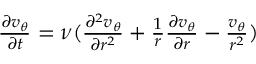Convert formula to latex. <formula><loc_0><loc_0><loc_500><loc_500>\begin{array} { r } { \frac { \partial v _ { \theta } } { \partial t } = \nu ( \frac { \partial ^ { 2 } v _ { \theta } } { \partial r ^ { 2 } } + \frac { 1 } { r } \frac { \partial v _ { \theta } } { \partial r } - \frac { v _ { \theta } } { r ^ { 2 } } ) } \end{array}</formula> 